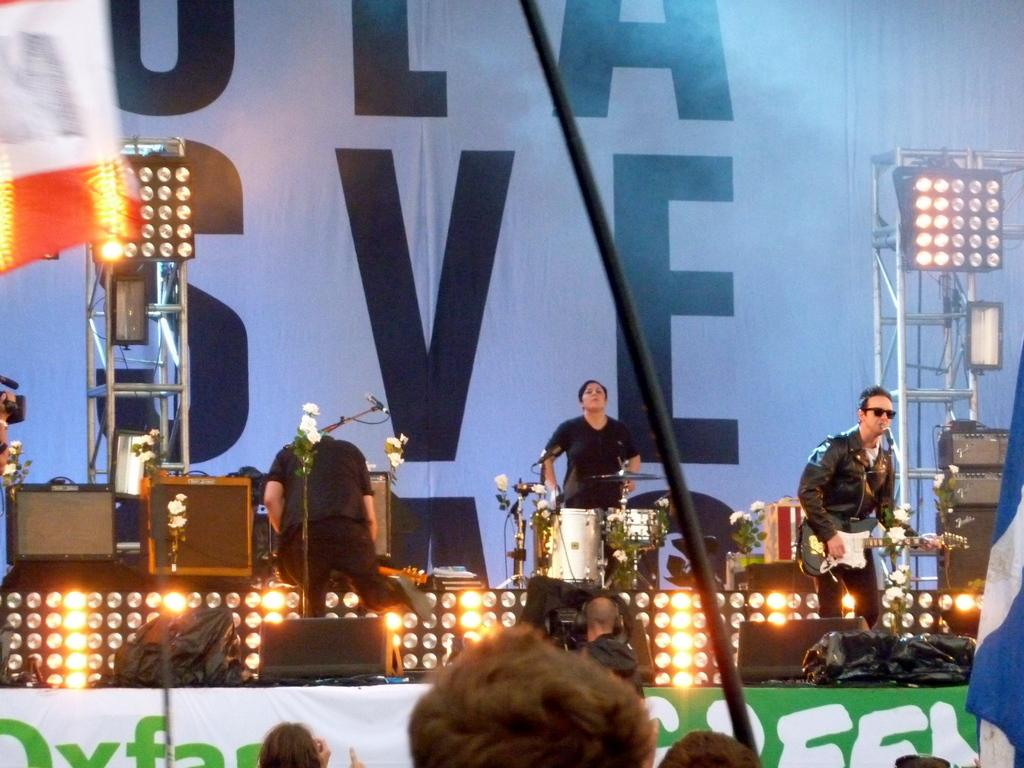What are the people in the image doing? A: The people in the image are standing and holding musical instruments. What can be seen in the background of the image? There is a huge banner, lights, and a stage visible in the background of the image. How many cubs are visible on the stage in the image? There are no cubs present in the image; it features people holding musical instruments and a stage in the background. What type of beds can be seen in the image? There are no beds present in the image. 